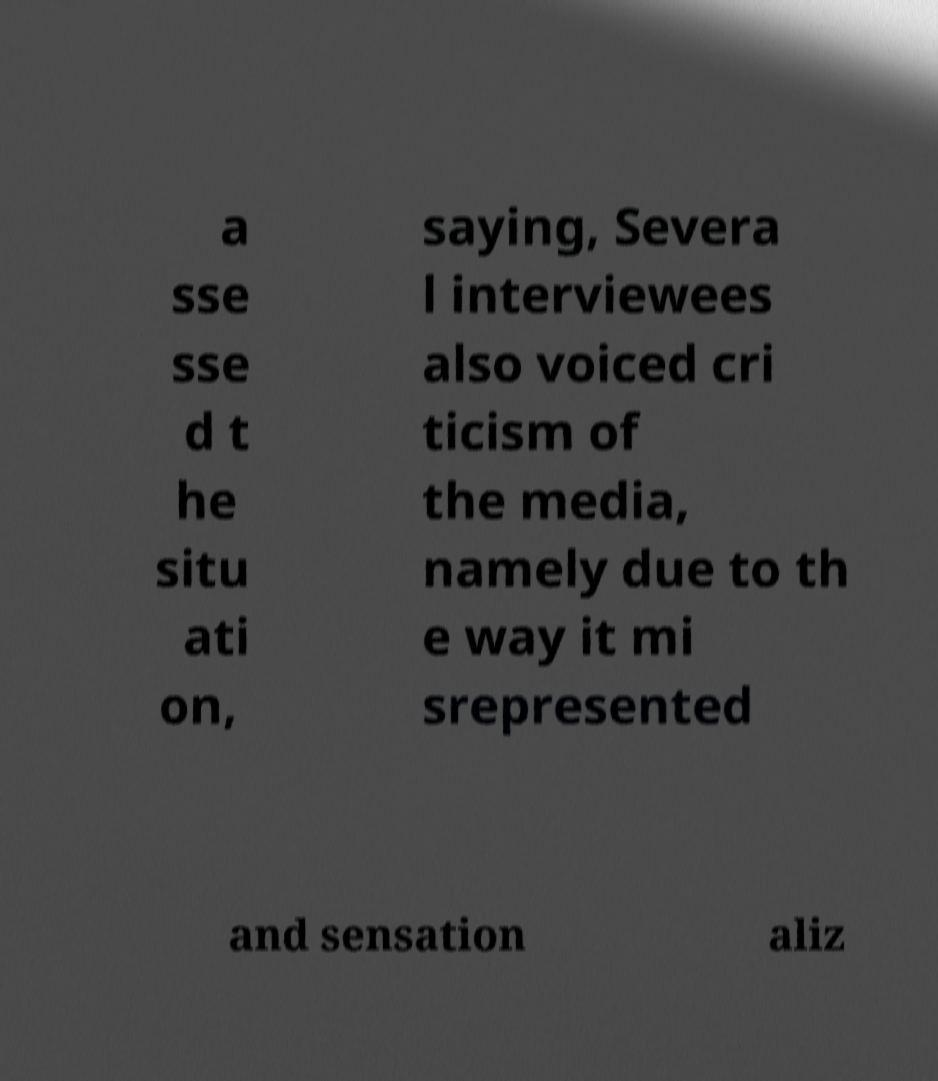I need the written content from this picture converted into text. Can you do that? a sse sse d t he situ ati on, saying, Severa l interviewees also voiced cri ticism of the media, namely due to th e way it mi srepresented and sensation aliz 